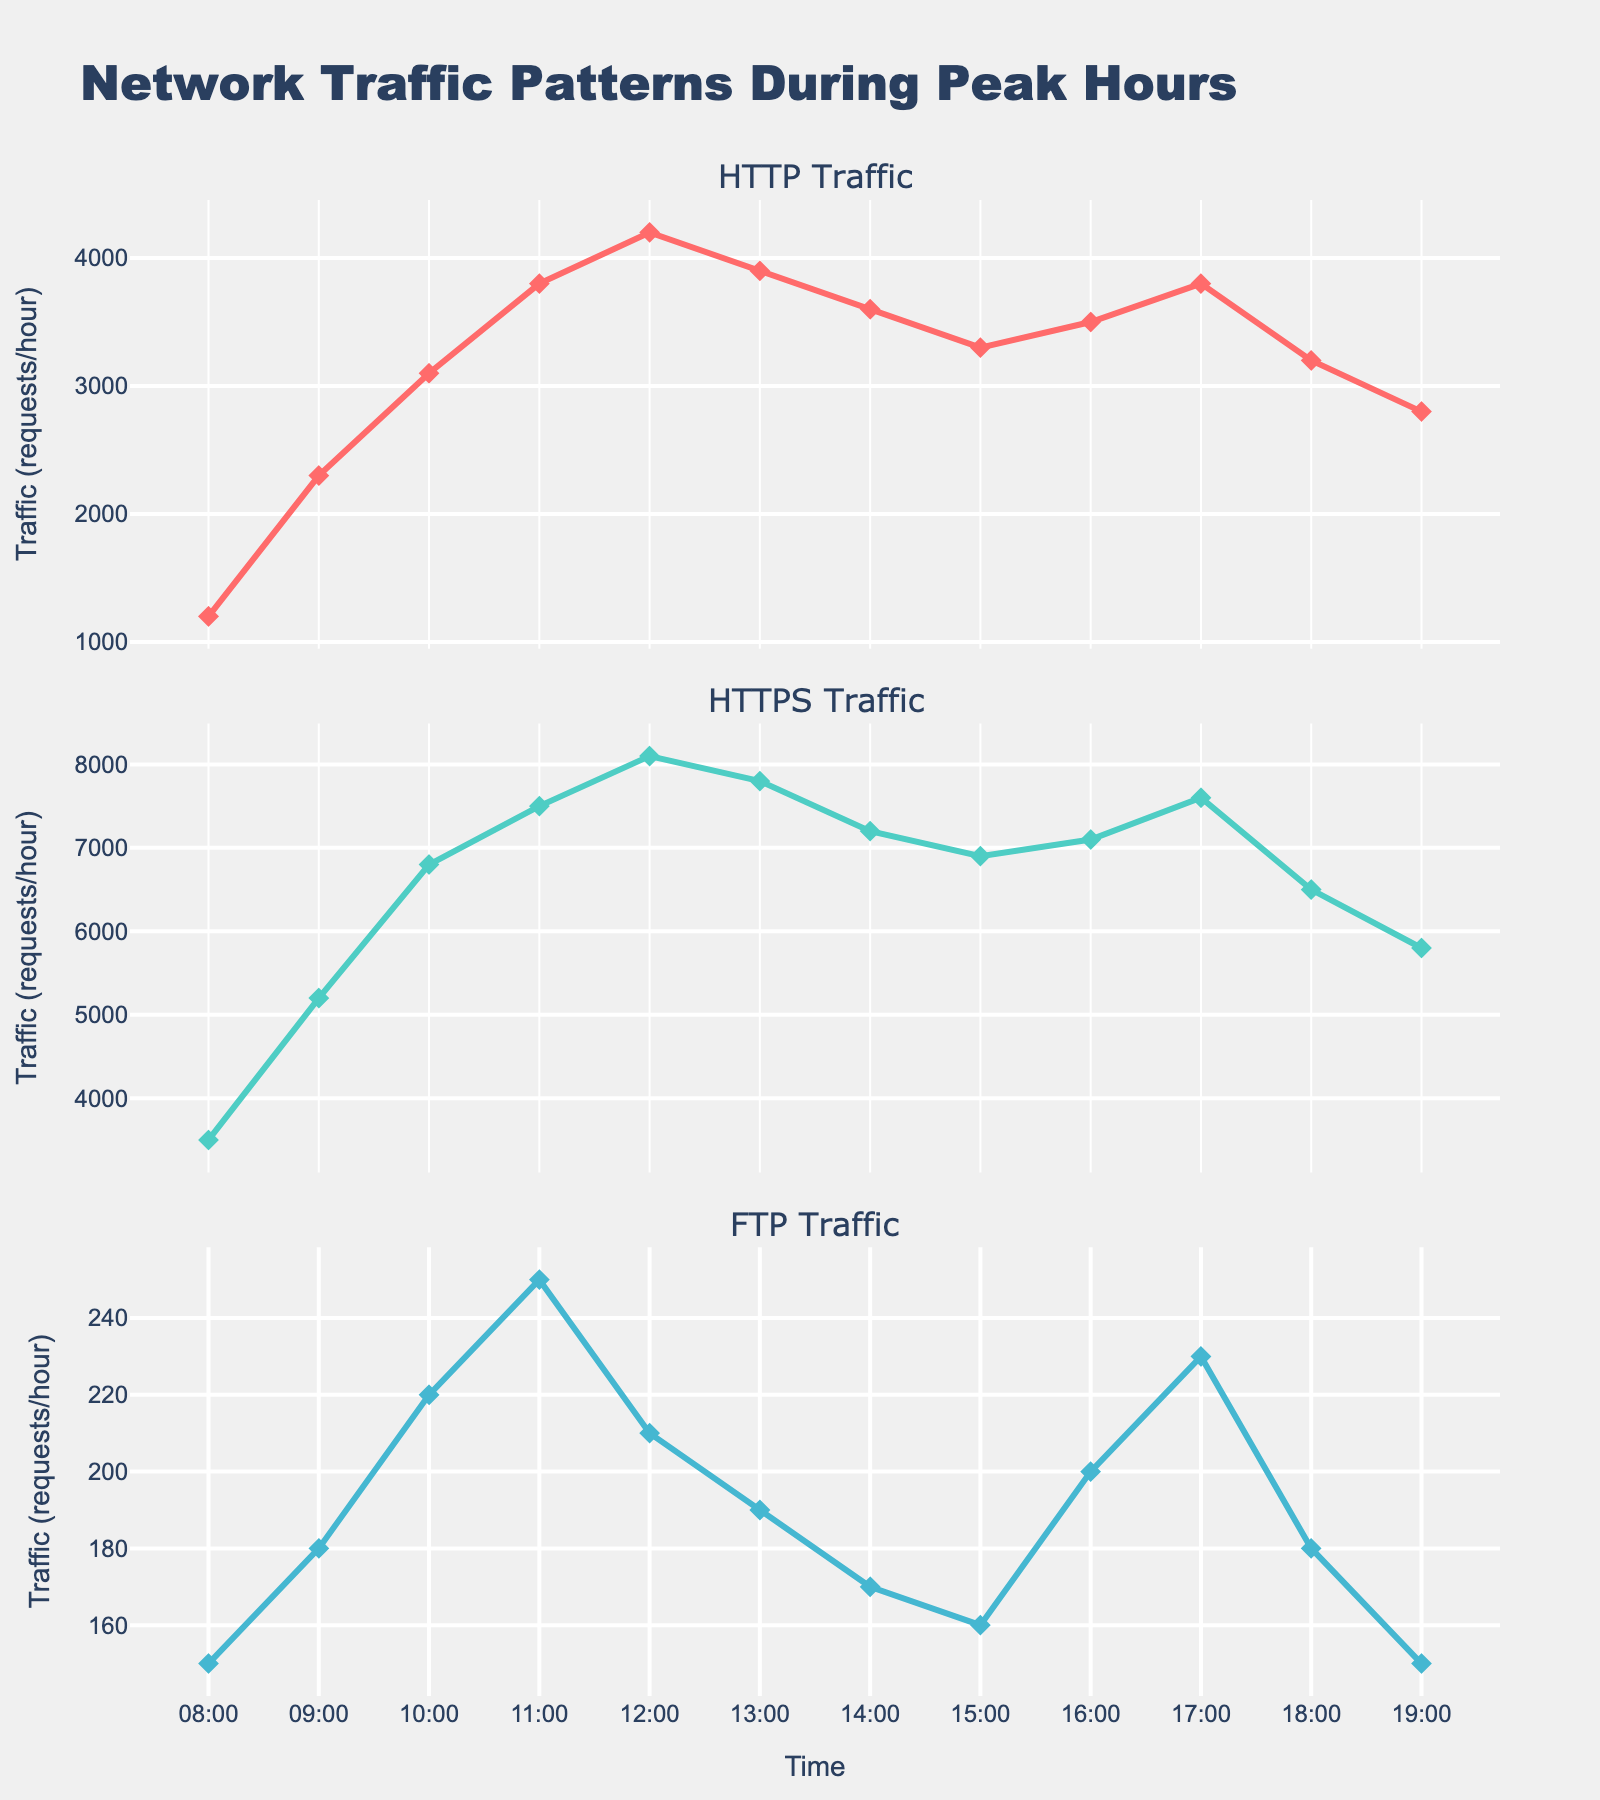What's the title of the figure? The title is prominently displayed at the top of the figure. It provides an overall description and context for the data being visualized.
Answer: Network Traffic Patterns During Peak Hours What is the traffic for HTTPS at 12:00? Locate the HTTPS subplot and find the data point corresponding to 12:00 on the x-axis. The y-axis value at this point indicates the traffic.
Answer: 8100 Which protocol had the highest traffic at 11:00? Compare the y-values for each protocol at 11:00 across the three subplots. Identify the protocol with the highest y-value.
Answer: HTTPS During which hour did HTTP traffic peak? Find the highest y-value in the HTTP subplot and note the corresponding x-axis value, which indicates the time.
Answer: 12:00 What is the range of traffic for FTP from 08:00 to 19:00? Identify the maximum and minimum y-values in the FTP subplot and subtract the minimum value from the maximum value to get the range.
Answer: 250 - 150 = 100 How does HTTPS traffic at 10:00 compare to HTTPS traffic at 18:00? Compare the y-values for HTTPS at 10:00 and 18:00 in the corresponding subplot. Determine if the traffic increased, decreased, or stayed the same.
Answer: Decreased (6800 to 6500) At what times do HTTP and FTP traffic intersect? Identify points in the HTTP and FTP subplots where the y-values are the same.
Answer: They intersect at no specific time What is the average HTTP traffic between 08:00 and 19:00? Sum the y-values for HTTP from 08:00 to 19:00 and divide by the number of data points (12) to find the average.
Answer: (Sum of HTTP values) / 12 = (1200 + 2300 + 3100 + 3800 + 4200 + 3900 + 3600 + 3300 + 3500 + 3800 + 3200 + 2800) / 12 = 3392 Which protocol shows the most fluctuation in traffic over the observed hours? Calculate the difference between the highest and lowest y-values for each protocol. The protocol with the largest difference shows the most fluctuation.
Answer: HTTPS (8100 - 3500 = 4600) What happens to HTTPS traffic after 15:00? Observe the trend in the HTTPS subplot after 15:00 by analyzing the y-values at 16:00, 17:00, 18:00, and 19:00.
Answer: It decreases from 6900 to 5800 